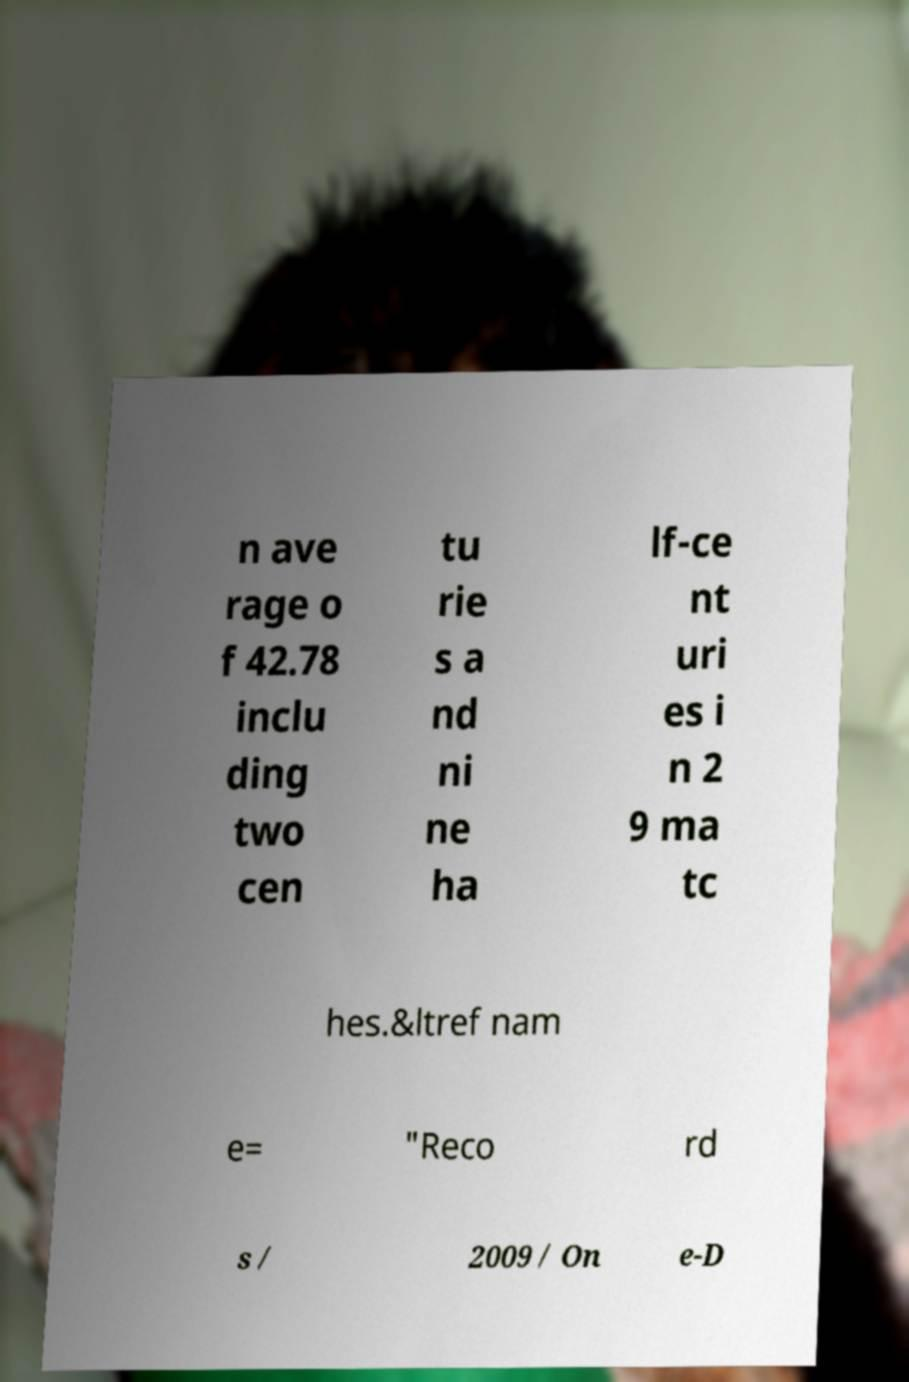Can you accurately transcribe the text from the provided image for me? n ave rage o f 42.78 inclu ding two cen tu rie s a nd ni ne ha lf-ce nt uri es i n 2 9 ma tc hes.&ltref nam e= "Reco rd s / 2009 / On e-D 